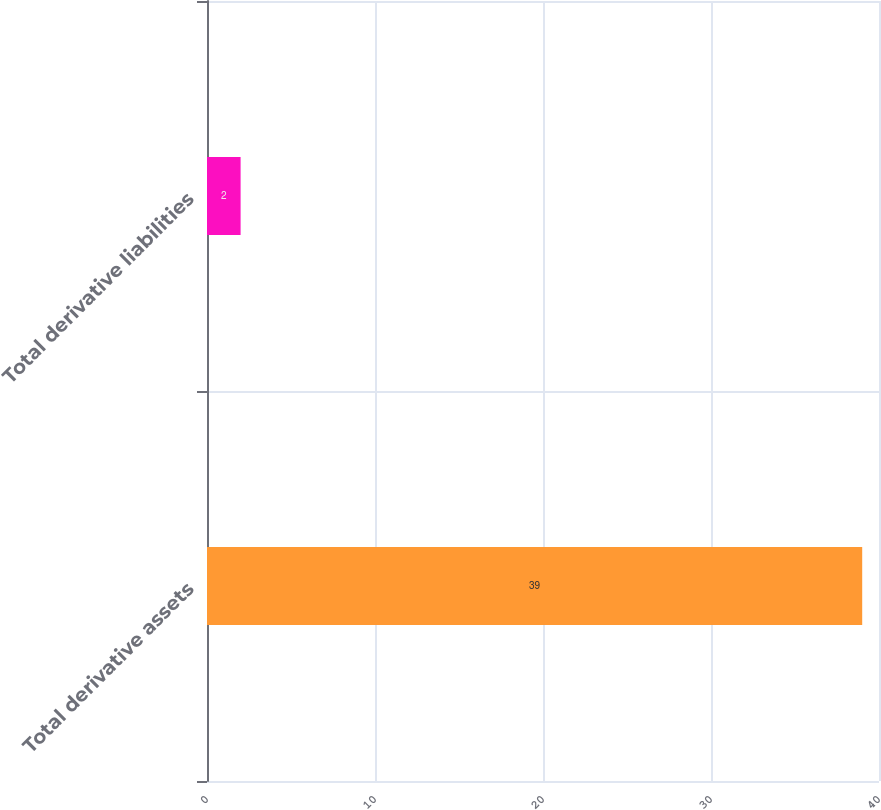Convert chart. <chart><loc_0><loc_0><loc_500><loc_500><bar_chart><fcel>Total derivative assets<fcel>Total derivative liabilities<nl><fcel>39<fcel>2<nl></chart> 